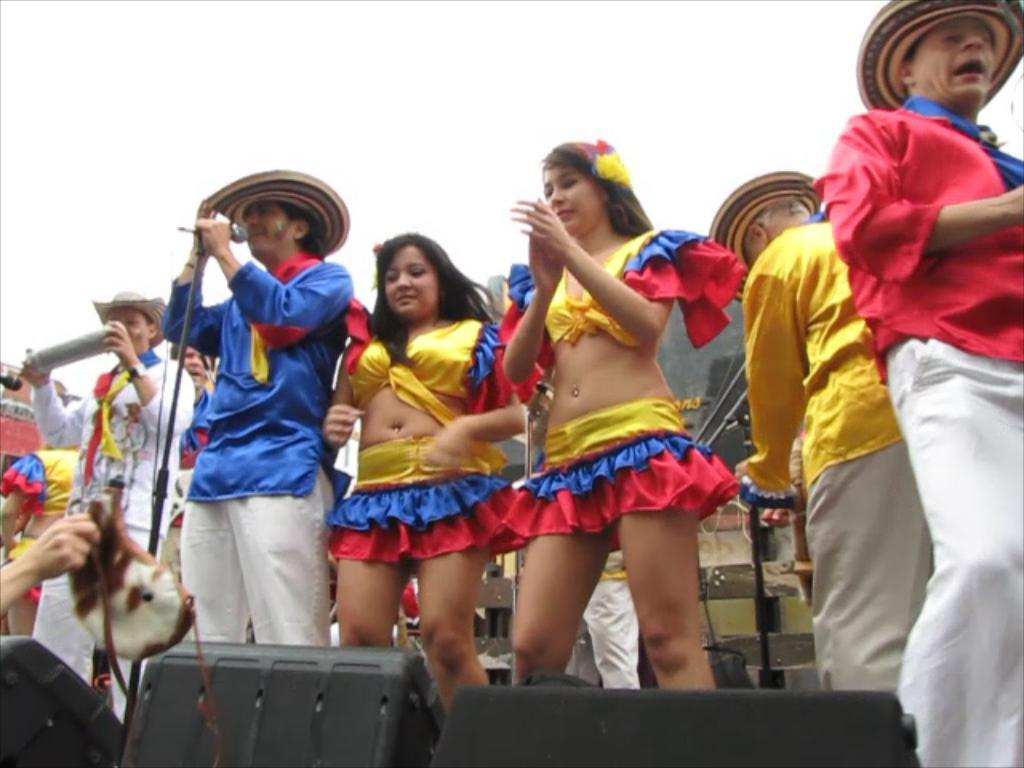What is happening on the stage in the image? There is a group of persons performing on the stage. What can be seen in the front of the stage? There are black objects in the front of the stage. What type of objects are on the stage? There are musical instruments on the stage. What type of trains are visible in the image? There are no trains present in the image. What hobbies do the performers on the stage have? The image does not provide information about the performers' hobbies. 